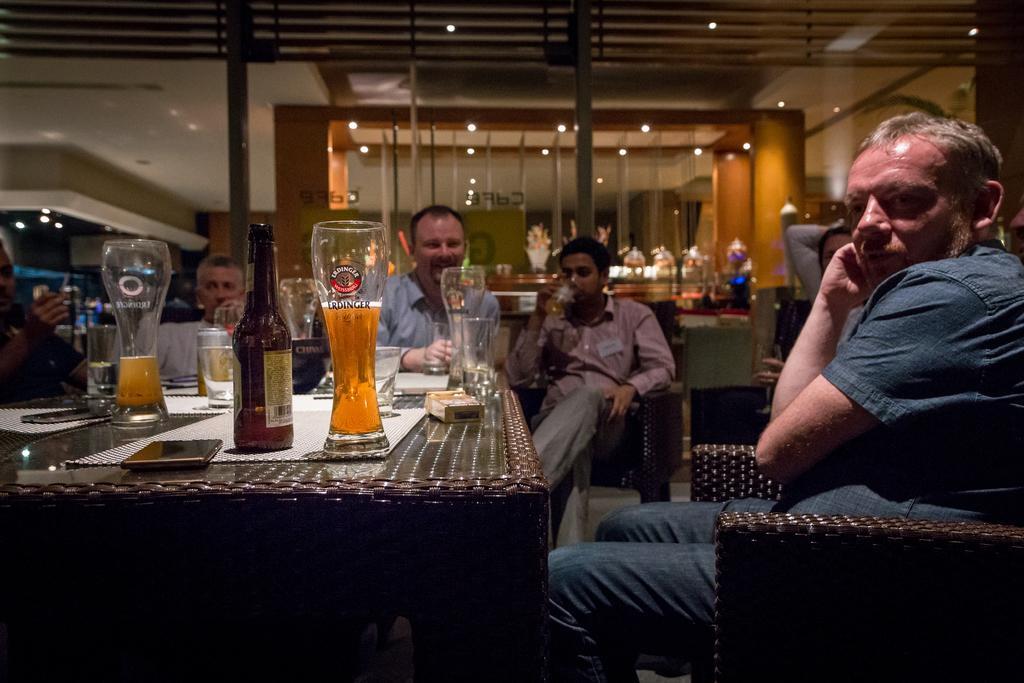Describe this image in one or two sentences. An indoor picture. This persons are sitting on chair. In-front of this person there is a table, on table there are glasses, bottle, bowl, mat, box and mobile. Far there are plants. 